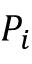Convert formula to latex. <formula><loc_0><loc_0><loc_500><loc_500>P _ { i }</formula> 